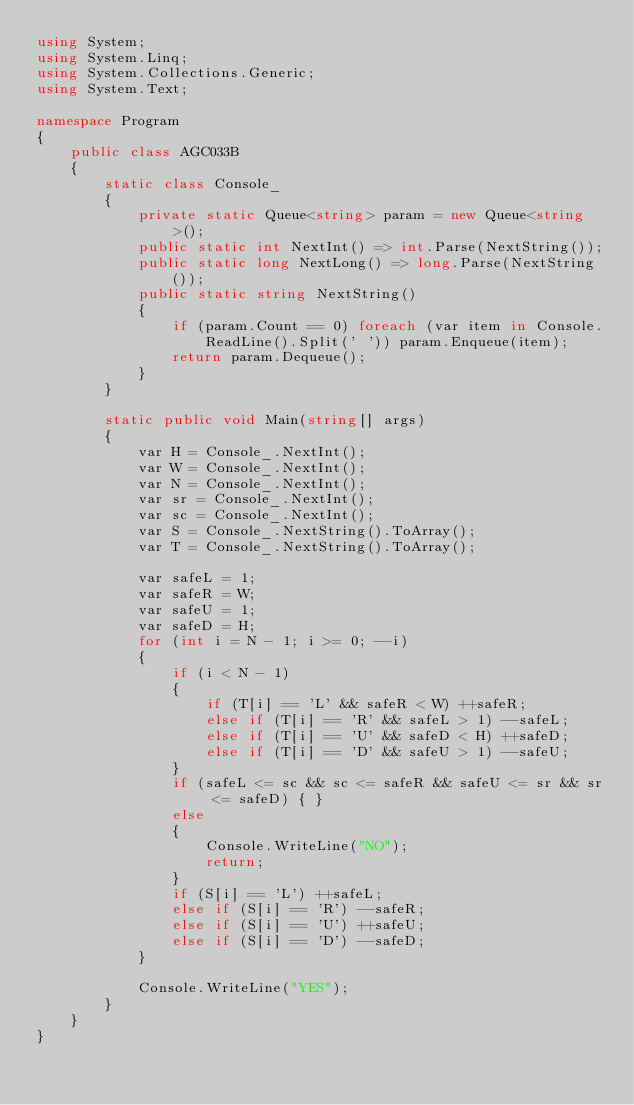Convert code to text. <code><loc_0><loc_0><loc_500><loc_500><_C#_>using System;
using System.Linq;
using System.Collections.Generic;
using System.Text;

namespace Program
{
    public class AGC033B
    {
        static class Console_
        {
            private static Queue<string> param = new Queue<string>();
            public static int NextInt() => int.Parse(NextString());
            public static long NextLong() => long.Parse(NextString());
            public static string NextString()
            {
                if (param.Count == 0) foreach (var item in Console.ReadLine().Split(' ')) param.Enqueue(item);
                return param.Dequeue();
            }
        }

        static public void Main(string[] args)
        {
            var H = Console_.NextInt();
            var W = Console_.NextInt();
            var N = Console_.NextInt();
            var sr = Console_.NextInt();
            var sc = Console_.NextInt();
            var S = Console_.NextString().ToArray();
            var T = Console_.NextString().ToArray();

            var safeL = 1;
            var safeR = W;
            var safeU = 1;
            var safeD = H;
            for (int i = N - 1; i >= 0; --i)
            {
                if (i < N - 1)
                {
                    if (T[i] == 'L' && safeR < W) ++safeR;
                    else if (T[i] == 'R' && safeL > 1) --safeL;
                    else if (T[i] == 'U' && safeD < H) ++safeD;
                    else if (T[i] == 'D' && safeU > 1) --safeU;
                }
                if (safeL <= sc && sc <= safeR && safeU <= sr && sr <= safeD) { }
                else
                {
                    Console.WriteLine("NO");
                    return;
                }
                if (S[i] == 'L') ++safeL;
                else if (S[i] == 'R') --safeR;
                else if (S[i] == 'U') ++safeU;
                else if (S[i] == 'D') --safeD;
            }

            Console.WriteLine("YES");
        }
    }
}
</code> 